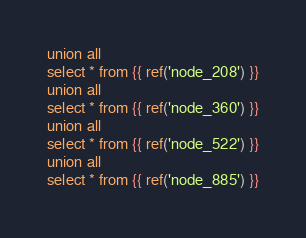<code> <loc_0><loc_0><loc_500><loc_500><_SQL_>union all
select * from {{ ref('node_208') }}
union all
select * from {{ ref('node_360') }}
union all
select * from {{ ref('node_522') }}
union all
select * from {{ ref('node_885') }}
</code> 